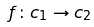<formula> <loc_0><loc_0><loc_500><loc_500>f \colon c _ { 1 } \rightarrow c _ { 2 }</formula> 